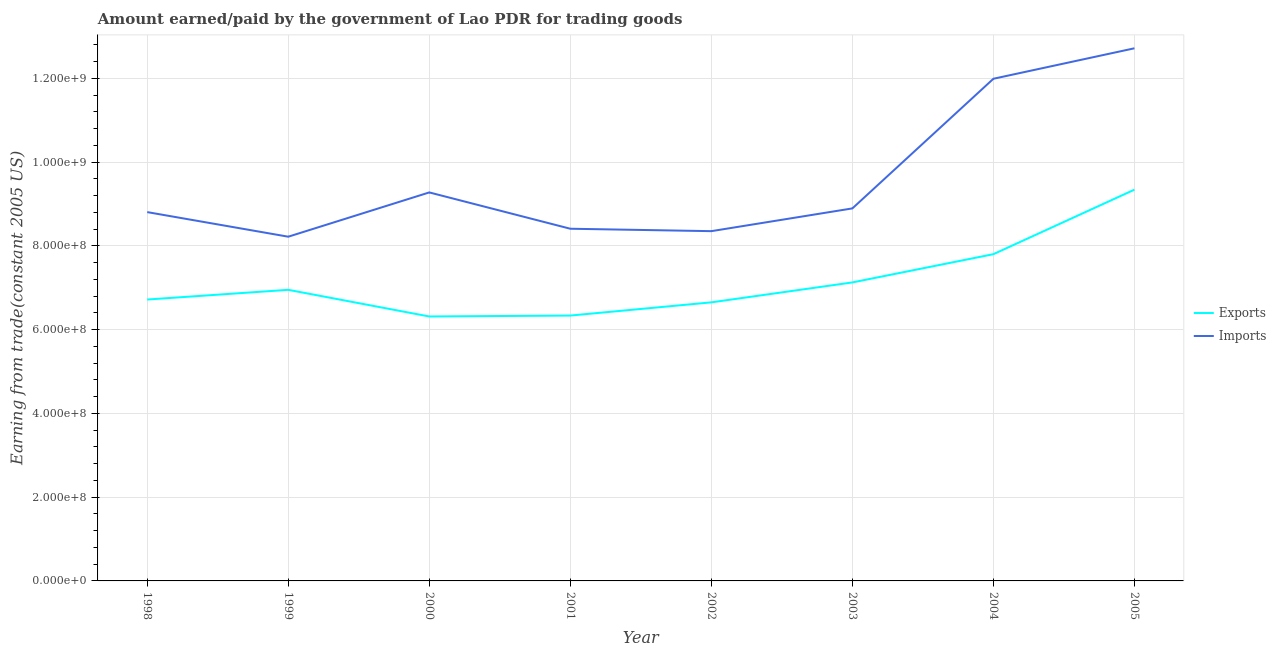How many different coloured lines are there?
Provide a succinct answer. 2. Is the number of lines equal to the number of legend labels?
Provide a succinct answer. Yes. What is the amount paid for imports in 2004?
Offer a very short reply. 1.20e+09. Across all years, what is the maximum amount earned from exports?
Make the answer very short. 9.34e+08. Across all years, what is the minimum amount paid for imports?
Give a very brief answer. 8.22e+08. In which year was the amount paid for imports maximum?
Your answer should be compact. 2005. In which year was the amount paid for imports minimum?
Your answer should be compact. 1999. What is the total amount paid for imports in the graph?
Offer a terse response. 7.67e+09. What is the difference between the amount paid for imports in 1999 and that in 2004?
Your response must be concise. -3.77e+08. What is the difference between the amount earned from exports in 1999 and the amount paid for imports in 2001?
Keep it short and to the point. -1.46e+08. What is the average amount earned from exports per year?
Ensure brevity in your answer.  7.16e+08. In the year 1999, what is the difference between the amount earned from exports and amount paid for imports?
Offer a very short reply. -1.27e+08. In how many years, is the amount paid for imports greater than 840000000 US$?
Ensure brevity in your answer.  6. What is the ratio of the amount paid for imports in 2000 to that in 2004?
Offer a terse response. 0.77. What is the difference between the highest and the second highest amount earned from exports?
Give a very brief answer. 1.54e+08. What is the difference between the highest and the lowest amount earned from exports?
Your answer should be compact. 3.03e+08. In how many years, is the amount earned from exports greater than the average amount earned from exports taken over all years?
Give a very brief answer. 2. Does the amount paid for imports monotonically increase over the years?
Offer a terse response. No. Is the amount earned from exports strictly greater than the amount paid for imports over the years?
Offer a very short reply. No. Does the graph contain any zero values?
Your response must be concise. No. What is the title of the graph?
Your answer should be compact. Amount earned/paid by the government of Lao PDR for trading goods. Does "Total Population" appear as one of the legend labels in the graph?
Your answer should be compact. No. What is the label or title of the X-axis?
Keep it short and to the point. Year. What is the label or title of the Y-axis?
Provide a succinct answer. Earning from trade(constant 2005 US). What is the Earning from trade(constant 2005 US) of Exports in 1998?
Provide a succinct answer. 6.72e+08. What is the Earning from trade(constant 2005 US) of Imports in 1998?
Give a very brief answer. 8.81e+08. What is the Earning from trade(constant 2005 US) of Exports in 1999?
Provide a short and direct response. 6.95e+08. What is the Earning from trade(constant 2005 US) of Imports in 1999?
Your answer should be very brief. 8.22e+08. What is the Earning from trade(constant 2005 US) in Exports in 2000?
Offer a very short reply. 6.32e+08. What is the Earning from trade(constant 2005 US) in Imports in 2000?
Keep it short and to the point. 9.28e+08. What is the Earning from trade(constant 2005 US) of Exports in 2001?
Offer a terse response. 6.34e+08. What is the Earning from trade(constant 2005 US) of Imports in 2001?
Keep it short and to the point. 8.41e+08. What is the Earning from trade(constant 2005 US) in Exports in 2002?
Offer a terse response. 6.65e+08. What is the Earning from trade(constant 2005 US) of Imports in 2002?
Provide a succinct answer. 8.35e+08. What is the Earning from trade(constant 2005 US) of Exports in 2003?
Your answer should be compact. 7.13e+08. What is the Earning from trade(constant 2005 US) in Imports in 2003?
Ensure brevity in your answer.  8.90e+08. What is the Earning from trade(constant 2005 US) in Exports in 2004?
Provide a succinct answer. 7.80e+08. What is the Earning from trade(constant 2005 US) in Imports in 2004?
Provide a succinct answer. 1.20e+09. What is the Earning from trade(constant 2005 US) in Exports in 2005?
Provide a short and direct response. 9.34e+08. What is the Earning from trade(constant 2005 US) in Imports in 2005?
Your answer should be compact. 1.27e+09. Across all years, what is the maximum Earning from trade(constant 2005 US) of Exports?
Your answer should be very brief. 9.34e+08. Across all years, what is the maximum Earning from trade(constant 2005 US) in Imports?
Offer a terse response. 1.27e+09. Across all years, what is the minimum Earning from trade(constant 2005 US) in Exports?
Provide a succinct answer. 6.32e+08. Across all years, what is the minimum Earning from trade(constant 2005 US) in Imports?
Ensure brevity in your answer.  8.22e+08. What is the total Earning from trade(constant 2005 US) in Exports in the graph?
Give a very brief answer. 5.73e+09. What is the total Earning from trade(constant 2005 US) of Imports in the graph?
Make the answer very short. 7.67e+09. What is the difference between the Earning from trade(constant 2005 US) of Exports in 1998 and that in 1999?
Give a very brief answer. -2.32e+07. What is the difference between the Earning from trade(constant 2005 US) of Imports in 1998 and that in 1999?
Provide a succinct answer. 5.87e+07. What is the difference between the Earning from trade(constant 2005 US) of Exports in 1998 and that in 2000?
Provide a short and direct response. 4.05e+07. What is the difference between the Earning from trade(constant 2005 US) in Imports in 1998 and that in 2000?
Keep it short and to the point. -4.70e+07. What is the difference between the Earning from trade(constant 2005 US) in Exports in 1998 and that in 2001?
Provide a succinct answer. 3.83e+07. What is the difference between the Earning from trade(constant 2005 US) in Imports in 1998 and that in 2001?
Make the answer very short. 3.97e+07. What is the difference between the Earning from trade(constant 2005 US) of Exports in 1998 and that in 2002?
Offer a terse response. 6.74e+06. What is the difference between the Earning from trade(constant 2005 US) of Imports in 1998 and that in 2002?
Make the answer very short. 4.55e+07. What is the difference between the Earning from trade(constant 2005 US) in Exports in 1998 and that in 2003?
Ensure brevity in your answer.  -4.09e+07. What is the difference between the Earning from trade(constant 2005 US) in Imports in 1998 and that in 2003?
Provide a short and direct response. -8.86e+06. What is the difference between the Earning from trade(constant 2005 US) of Exports in 1998 and that in 2004?
Provide a succinct answer. -1.08e+08. What is the difference between the Earning from trade(constant 2005 US) in Imports in 1998 and that in 2004?
Provide a short and direct response. -3.18e+08. What is the difference between the Earning from trade(constant 2005 US) of Exports in 1998 and that in 2005?
Give a very brief answer. -2.62e+08. What is the difference between the Earning from trade(constant 2005 US) in Imports in 1998 and that in 2005?
Your answer should be very brief. -3.91e+08. What is the difference between the Earning from trade(constant 2005 US) of Exports in 1999 and that in 2000?
Provide a short and direct response. 6.36e+07. What is the difference between the Earning from trade(constant 2005 US) of Imports in 1999 and that in 2000?
Give a very brief answer. -1.06e+08. What is the difference between the Earning from trade(constant 2005 US) in Exports in 1999 and that in 2001?
Provide a short and direct response. 6.15e+07. What is the difference between the Earning from trade(constant 2005 US) of Imports in 1999 and that in 2001?
Offer a terse response. -1.90e+07. What is the difference between the Earning from trade(constant 2005 US) of Exports in 1999 and that in 2002?
Provide a succinct answer. 2.99e+07. What is the difference between the Earning from trade(constant 2005 US) of Imports in 1999 and that in 2002?
Make the answer very short. -1.32e+07. What is the difference between the Earning from trade(constant 2005 US) in Exports in 1999 and that in 2003?
Provide a short and direct response. -1.77e+07. What is the difference between the Earning from trade(constant 2005 US) in Imports in 1999 and that in 2003?
Ensure brevity in your answer.  -6.76e+07. What is the difference between the Earning from trade(constant 2005 US) in Exports in 1999 and that in 2004?
Your answer should be very brief. -8.52e+07. What is the difference between the Earning from trade(constant 2005 US) in Imports in 1999 and that in 2004?
Make the answer very short. -3.77e+08. What is the difference between the Earning from trade(constant 2005 US) of Exports in 1999 and that in 2005?
Provide a short and direct response. -2.39e+08. What is the difference between the Earning from trade(constant 2005 US) in Imports in 1999 and that in 2005?
Provide a short and direct response. -4.50e+08. What is the difference between the Earning from trade(constant 2005 US) in Exports in 2000 and that in 2001?
Offer a very short reply. -2.19e+06. What is the difference between the Earning from trade(constant 2005 US) in Imports in 2000 and that in 2001?
Provide a succinct answer. 8.67e+07. What is the difference between the Earning from trade(constant 2005 US) in Exports in 2000 and that in 2002?
Your answer should be very brief. -3.37e+07. What is the difference between the Earning from trade(constant 2005 US) of Imports in 2000 and that in 2002?
Your answer should be very brief. 9.25e+07. What is the difference between the Earning from trade(constant 2005 US) in Exports in 2000 and that in 2003?
Keep it short and to the point. -8.13e+07. What is the difference between the Earning from trade(constant 2005 US) in Imports in 2000 and that in 2003?
Offer a terse response. 3.82e+07. What is the difference between the Earning from trade(constant 2005 US) in Exports in 2000 and that in 2004?
Your answer should be very brief. -1.49e+08. What is the difference between the Earning from trade(constant 2005 US) in Imports in 2000 and that in 2004?
Make the answer very short. -2.71e+08. What is the difference between the Earning from trade(constant 2005 US) in Exports in 2000 and that in 2005?
Offer a very short reply. -3.03e+08. What is the difference between the Earning from trade(constant 2005 US) of Imports in 2000 and that in 2005?
Provide a succinct answer. -3.44e+08. What is the difference between the Earning from trade(constant 2005 US) of Exports in 2001 and that in 2002?
Ensure brevity in your answer.  -3.15e+07. What is the difference between the Earning from trade(constant 2005 US) in Imports in 2001 and that in 2002?
Offer a terse response. 5.79e+06. What is the difference between the Earning from trade(constant 2005 US) of Exports in 2001 and that in 2003?
Your answer should be compact. -7.91e+07. What is the difference between the Earning from trade(constant 2005 US) of Imports in 2001 and that in 2003?
Give a very brief answer. -4.86e+07. What is the difference between the Earning from trade(constant 2005 US) of Exports in 2001 and that in 2004?
Your answer should be very brief. -1.47e+08. What is the difference between the Earning from trade(constant 2005 US) in Imports in 2001 and that in 2004?
Your answer should be compact. -3.58e+08. What is the difference between the Earning from trade(constant 2005 US) in Exports in 2001 and that in 2005?
Keep it short and to the point. -3.01e+08. What is the difference between the Earning from trade(constant 2005 US) of Imports in 2001 and that in 2005?
Keep it short and to the point. -4.31e+08. What is the difference between the Earning from trade(constant 2005 US) in Exports in 2002 and that in 2003?
Offer a very short reply. -4.76e+07. What is the difference between the Earning from trade(constant 2005 US) in Imports in 2002 and that in 2003?
Offer a terse response. -5.43e+07. What is the difference between the Earning from trade(constant 2005 US) in Exports in 2002 and that in 2004?
Offer a very short reply. -1.15e+08. What is the difference between the Earning from trade(constant 2005 US) in Imports in 2002 and that in 2004?
Your response must be concise. -3.64e+08. What is the difference between the Earning from trade(constant 2005 US) of Exports in 2002 and that in 2005?
Provide a short and direct response. -2.69e+08. What is the difference between the Earning from trade(constant 2005 US) in Imports in 2002 and that in 2005?
Your response must be concise. -4.37e+08. What is the difference between the Earning from trade(constant 2005 US) of Exports in 2003 and that in 2004?
Provide a succinct answer. -6.75e+07. What is the difference between the Earning from trade(constant 2005 US) of Imports in 2003 and that in 2004?
Provide a succinct answer. -3.10e+08. What is the difference between the Earning from trade(constant 2005 US) of Exports in 2003 and that in 2005?
Provide a short and direct response. -2.22e+08. What is the difference between the Earning from trade(constant 2005 US) in Imports in 2003 and that in 2005?
Your answer should be very brief. -3.82e+08. What is the difference between the Earning from trade(constant 2005 US) in Exports in 2004 and that in 2005?
Provide a short and direct response. -1.54e+08. What is the difference between the Earning from trade(constant 2005 US) in Imports in 2004 and that in 2005?
Provide a short and direct response. -7.28e+07. What is the difference between the Earning from trade(constant 2005 US) of Exports in 1998 and the Earning from trade(constant 2005 US) of Imports in 1999?
Provide a short and direct response. -1.50e+08. What is the difference between the Earning from trade(constant 2005 US) in Exports in 1998 and the Earning from trade(constant 2005 US) in Imports in 2000?
Offer a terse response. -2.56e+08. What is the difference between the Earning from trade(constant 2005 US) of Exports in 1998 and the Earning from trade(constant 2005 US) of Imports in 2001?
Ensure brevity in your answer.  -1.69e+08. What is the difference between the Earning from trade(constant 2005 US) of Exports in 1998 and the Earning from trade(constant 2005 US) of Imports in 2002?
Offer a terse response. -1.63e+08. What is the difference between the Earning from trade(constant 2005 US) in Exports in 1998 and the Earning from trade(constant 2005 US) in Imports in 2003?
Offer a very short reply. -2.18e+08. What is the difference between the Earning from trade(constant 2005 US) in Exports in 1998 and the Earning from trade(constant 2005 US) in Imports in 2004?
Your answer should be very brief. -5.27e+08. What is the difference between the Earning from trade(constant 2005 US) in Exports in 1998 and the Earning from trade(constant 2005 US) in Imports in 2005?
Make the answer very short. -6.00e+08. What is the difference between the Earning from trade(constant 2005 US) in Exports in 1999 and the Earning from trade(constant 2005 US) in Imports in 2000?
Ensure brevity in your answer.  -2.33e+08. What is the difference between the Earning from trade(constant 2005 US) of Exports in 1999 and the Earning from trade(constant 2005 US) of Imports in 2001?
Your answer should be compact. -1.46e+08. What is the difference between the Earning from trade(constant 2005 US) of Exports in 1999 and the Earning from trade(constant 2005 US) of Imports in 2002?
Your answer should be compact. -1.40e+08. What is the difference between the Earning from trade(constant 2005 US) in Exports in 1999 and the Earning from trade(constant 2005 US) in Imports in 2003?
Your answer should be compact. -1.94e+08. What is the difference between the Earning from trade(constant 2005 US) of Exports in 1999 and the Earning from trade(constant 2005 US) of Imports in 2004?
Offer a very short reply. -5.04e+08. What is the difference between the Earning from trade(constant 2005 US) in Exports in 1999 and the Earning from trade(constant 2005 US) in Imports in 2005?
Make the answer very short. -5.77e+08. What is the difference between the Earning from trade(constant 2005 US) in Exports in 2000 and the Earning from trade(constant 2005 US) in Imports in 2001?
Give a very brief answer. -2.10e+08. What is the difference between the Earning from trade(constant 2005 US) in Exports in 2000 and the Earning from trade(constant 2005 US) in Imports in 2002?
Give a very brief answer. -2.04e+08. What is the difference between the Earning from trade(constant 2005 US) of Exports in 2000 and the Earning from trade(constant 2005 US) of Imports in 2003?
Your response must be concise. -2.58e+08. What is the difference between the Earning from trade(constant 2005 US) of Exports in 2000 and the Earning from trade(constant 2005 US) of Imports in 2004?
Give a very brief answer. -5.68e+08. What is the difference between the Earning from trade(constant 2005 US) of Exports in 2000 and the Earning from trade(constant 2005 US) of Imports in 2005?
Provide a short and direct response. -6.40e+08. What is the difference between the Earning from trade(constant 2005 US) of Exports in 2001 and the Earning from trade(constant 2005 US) of Imports in 2002?
Ensure brevity in your answer.  -2.02e+08. What is the difference between the Earning from trade(constant 2005 US) in Exports in 2001 and the Earning from trade(constant 2005 US) in Imports in 2003?
Ensure brevity in your answer.  -2.56e+08. What is the difference between the Earning from trade(constant 2005 US) of Exports in 2001 and the Earning from trade(constant 2005 US) of Imports in 2004?
Your answer should be compact. -5.66e+08. What is the difference between the Earning from trade(constant 2005 US) in Exports in 2001 and the Earning from trade(constant 2005 US) in Imports in 2005?
Give a very brief answer. -6.38e+08. What is the difference between the Earning from trade(constant 2005 US) in Exports in 2002 and the Earning from trade(constant 2005 US) in Imports in 2003?
Your response must be concise. -2.24e+08. What is the difference between the Earning from trade(constant 2005 US) of Exports in 2002 and the Earning from trade(constant 2005 US) of Imports in 2004?
Ensure brevity in your answer.  -5.34e+08. What is the difference between the Earning from trade(constant 2005 US) in Exports in 2002 and the Earning from trade(constant 2005 US) in Imports in 2005?
Give a very brief answer. -6.07e+08. What is the difference between the Earning from trade(constant 2005 US) in Exports in 2003 and the Earning from trade(constant 2005 US) in Imports in 2004?
Ensure brevity in your answer.  -4.86e+08. What is the difference between the Earning from trade(constant 2005 US) in Exports in 2003 and the Earning from trade(constant 2005 US) in Imports in 2005?
Give a very brief answer. -5.59e+08. What is the difference between the Earning from trade(constant 2005 US) of Exports in 2004 and the Earning from trade(constant 2005 US) of Imports in 2005?
Your answer should be very brief. -4.92e+08. What is the average Earning from trade(constant 2005 US) of Exports per year?
Offer a terse response. 7.16e+08. What is the average Earning from trade(constant 2005 US) of Imports per year?
Ensure brevity in your answer.  9.58e+08. In the year 1998, what is the difference between the Earning from trade(constant 2005 US) in Exports and Earning from trade(constant 2005 US) in Imports?
Provide a succinct answer. -2.09e+08. In the year 1999, what is the difference between the Earning from trade(constant 2005 US) in Exports and Earning from trade(constant 2005 US) in Imports?
Make the answer very short. -1.27e+08. In the year 2000, what is the difference between the Earning from trade(constant 2005 US) in Exports and Earning from trade(constant 2005 US) in Imports?
Your response must be concise. -2.96e+08. In the year 2001, what is the difference between the Earning from trade(constant 2005 US) of Exports and Earning from trade(constant 2005 US) of Imports?
Your answer should be very brief. -2.07e+08. In the year 2002, what is the difference between the Earning from trade(constant 2005 US) in Exports and Earning from trade(constant 2005 US) in Imports?
Ensure brevity in your answer.  -1.70e+08. In the year 2003, what is the difference between the Earning from trade(constant 2005 US) in Exports and Earning from trade(constant 2005 US) in Imports?
Keep it short and to the point. -1.77e+08. In the year 2004, what is the difference between the Earning from trade(constant 2005 US) in Exports and Earning from trade(constant 2005 US) in Imports?
Your answer should be very brief. -4.19e+08. In the year 2005, what is the difference between the Earning from trade(constant 2005 US) in Exports and Earning from trade(constant 2005 US) in Imports?
Offer a very short reply. -3.38e+08. What is the ratio of the Earning from trade(constant 2005 US) in Exports in 1998 to that in 1999?
Ensure brevity in your answer.  0.97. What is the ratio of the Earning from trade(constant 2005 US) in Imports in 1998 to that in 1999?
Your response must be concise. 1.07. What is the ratio of the Earning from trade(constant 2005 US) in Exports in 1998 to that in 2000?
Offer a very short reply. 1.06. What is the ratio of the Earning from trade(constant 2005 US) of Imports in 1998 to that in 2000?
Your answer should be compact. 0.95. What is the ratio of the Earning from trade(constant 2005 US) of Exports in 1998 to that in 2001?
Your response must be concise. 1.06. What is the ratio of the Earning from trade(constant 2005 US) of Imports in 1998 to that in 2001?
Ensure brevity in your answer.  1.05. What is the ratio of the Earning from trade(constant 2005 US) in Imports in 1998 to that in 2002?
Provide a short and direct response. 1.05. What is the ratio of the Earning from trade(constant 2005 US) in Exports in 1998 to that in 2003?
Offer a very short reply. 0.94. What is the ratio of the Earning from trade(constant 2005 US) of Exports in 1998 to that in 2004?
Make the answer very short. 0.86. What is the ratio of the Earning from trade(constant 2005 US) in Imports in 1998 to that in 2004?
Ensure brevity in your answer.  0.73. What is the ratio of the Earning from trade(constant 2005 US) of Exports in 1998 to that in 2005?
Your answer should be very brief. 0.72. What is the ratio of the Earning from trade(constant 2005 US) in Imports in 1998 to that in 2005?
Your answer should be compact. 0.69. What is the ratio of the Earning from trade(constant 2005 US) in Exports in 1999 to that in 2000?
Provide a succinct answer. 1.1. What is the ratio of the Earning from trade(constant 2005 US) of Imports in 1999 to that in 2000?
Give a very brief answer. 0.89. What is the ratio of the Earning from trade(constant 2005 US) of Exports in 1999 to that in 2001?
Provide a short and direct response. 1.1. What is the ratio of the Earning from trade(constant 2005 US) in Imports in 1999 to that in 2001?
Your response must be concise. 0.98. What is the ratio of the Earning from trade(constant 2005 US) of Exports in 1999 to that in 2002?
Offer a very short reply. 1.04. What is the ratio of the Earning from trade(constant 2005 US) in Imports in 1999 to that in 2002?
Provide a short and direct response. 0.98. What is the ratio of the Earning from trade(constant 2005 US) of Exports in 1999 to that in 2003?
Offer a very short reply. 0.98. What is the ratio of the Earning from trade(constant 2005 US) of Imports in 1999 to that in 2003?
Offer a terse response. 0.92. What is the ratio of the Earning from trade(constant 2005 US) in Exports in 1999 to that in 2004?
Provide a short and direct response. 0.89. What is the ratio of the Earning from trade(constant 2005 US) of Imports in 1999 to that in 2004?
Your answer should be very brief. 0.69. What is the ratio of the Earning from trade(constant 2005 US) of Exports in 1999 to that in 2005?
Provide a short and direct response. 0.74. What is the ratio of the Earning from trade(constant 2005 US) of Imports in 1999 to that in 2005?
Provide a succinct answer. 0.65. What is the ratio of the Earning from trade(constant 2005 US) of Exports in 2000 to that in 2001?
Give a very brief answer. 1. What is the ratio of the Earning from trade(constant 2005 US) in Imports in 2000 to that in 2001?
Keep it short and to the point. 1.1. What is the ratio of the Earning from trade(constant 2005 US) of Exports in 2000 to that in 2002?
Give a very brief answer. 0.95. What is the ratio of the Earning from trade(constant 2005 US) in Imports in 2000 to that in 2002?
Ensure brevity in your answer.  1.11. What is the ratio of the Earning from trade(constant 2005 US) of Exports in 2000 to that in 2003?
Provide a succinct answer. 0.89. What is the ratio of the Earning from trade(constant 2005 US) of Imports in 2000 to that in 2003?
Keep it short and to the point. 1.04. What is the ratio of the Earning from trade(constant 2005 US) in Exports in 2000 to that in 2004?
Make the answer very short. 0.81. What is the ratio of the Earning from trade(constant 2005 US) in Imports in 2000 to that in 2004?
Offer a terse response. 0.77. What is the ratio of the Earning from trade(constant 2005 US) in Exports in 2000 to that in 2005?
Your response must be concise. 0.68. What is the ratio of the Earning from trade(constant 2005 US) of Imports in 2000 to that in 2005?
Offer a terse response. 0.73. What is the ratio of the Earning from trade(constant 2005 US) in Exports in 2001 to that in 2002?
Make the answer very short. 0.95. What is the ratio of the Earning from trade(constant 2005 US) of Exports in 2001 to that in 2003?
Keep it short and to the point. 0.89. What is the ratio of the Earning from trade(constant 2005 US) of Imports in 2001 to that in 2003?
Your response must be concise. 0.95. What is the ratio of the Earning from trade(constant 2005 US) of Exports in 2001 to that in 2004?
Make the answer very short. 0.81. What is the ratio of the Earning from trade(constant 2005 US) in Imports in 2001 to that in 2004?
Offer a very short reply. 0.7. What is the ratio of the Earning from trade(constant 2005 US) of Exports in 2001 to that in 2005?
Provide a short and direct response. 0.68. What is the ratio of the Earning from trade(constant 2005 US) in Imports in 2001 to that in 2005?
Ensure brevity in your answer.  0.66. What is the ratio of the Earning from trade(constant 2005 US) of Exports in 2002 to that in 2003?
Give a very brief answer. 0.93. What is the ratio of the Earning from trade(constant 2005 US) of Imports in 2002 to that in 2003?
Provide a succinct answer. 0.94. What is the ratio of the Earning from trade(constant 2005 US) of Exports in 2002 to that in 2004?
Provide a succinct answer. 0.85. What is the ratio of the Earning from trade(constant 2005 US) in Imports in 2002 to that in 2004?
Offer a terse response. 0.7. What is the ratio of the Earning from trade(constant 2005 US) of Exports in 2002 to that in 2005?
Your answer should be very brief. 0.71. What is the ratio of the Earning from trade(constant 2005 US) of Imports in 2002 to that in 2005?
Your answer should be compact. 0.66. What is the ratio of the Earning from trade(constant 2005 US) in Exports in 2003 to that in 2004?
Offer a terse response. 0.91. What is the ratio of the Earning from trade(constant 2005 US) in Imports in 2003 to that in 2004?
Offer a terse response. 0.74. What is the ratio of the Earning from trade(constant 2005 US) of Exports in 2003 to that in 2005?
Make the answer very short. 0.76. What is the ratio of the Earning from trade(constant 2005 US) of Imports in 2003 to that in 2005?
Ensure brevity in your answer.  0.7. What is the ratio of the Earning from trade(constant 2005 US) in Exports in 2004 to that in 2005?
Provide a short and direct response. 0.84. What is the ratio of the Earning from trade(constant 2005 US) of Imports in 2004 to that in 2005?
Keep it short and to the point. 0.94. What is the difference between the highest and the second highest Earning from trade(constant 2005 US) of Exports?
Make the answer very short. 1.54e+08. What is the difference between the highest and the second highest Earning from trade(constant 2005 US) in Imports?
Make the answer very short. 7.28e+07. What is the difference between the highest and the lowest Earning from trade(constant 2005 US) of Exports?
Your answer should be very brief. 3.03e+08. What is the difference between the highest and the lowest Earning from trade(constant 2005 US) of Imports?
Make the answer very short. 4.50e+08. 